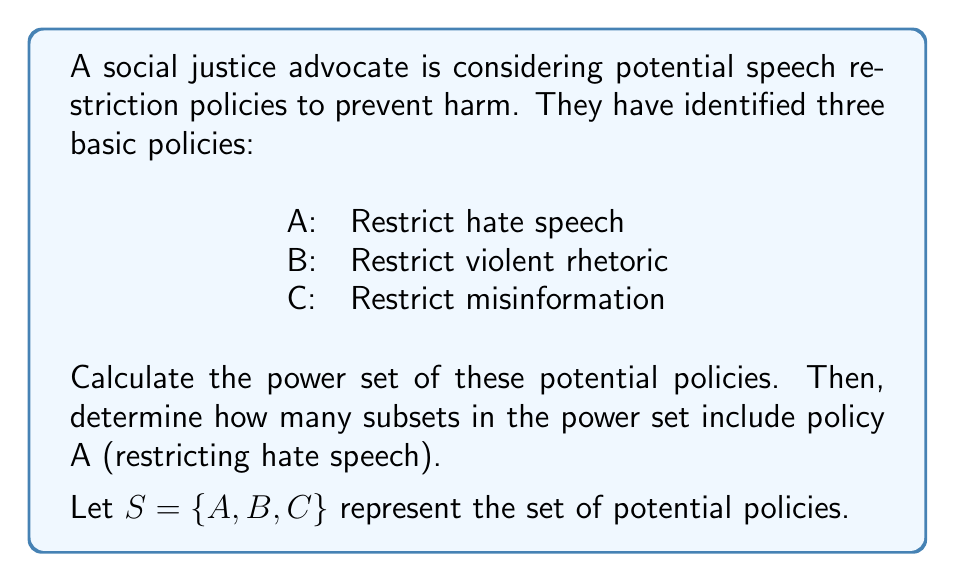Provide a solution to this math problem. To solve this problem, we'll follow these steps:

1) First, let's compute the power set of $S$:
   The power set $P(S)$ is the set of all subsets of $S$, including the empty set and $S$ itself.

   $P(S) = \{\emptyset, \{A\}, \{B\}, \{C\}, \{A,B\}, \{A,C\}, \{B,C\}, \{A,B,C\}\}$

2) To determine the number of elements in the power set:
   For a set with $n$ elements, the power set has $2^n$ elements.
   Here, $|S| = 3$, so $|P(S)| = 2^3 = 8$

3) To count how many subsets include policy A:
   We can see that $\{A\}$, $\{A,B\}$, $\{A,C\}$, and $\{A,B,C\}$ include A.
   There are 4 such subsets.

Alternatively, we can calculate this:
   - Total subsets: $2^3 = 8$
   - Subsets without A: $2^2 = 4$ (as if A didn't exist)
   - Subsets with A: $8 - 4 = 4$
Answer: $P(S) = \{\emptyset, \{A\}, \{B\}, \{C\}, \{A,B\}, \{A,C\}, \{B,C\}, \{A,B,C\}\}$; 4 subsets include A 